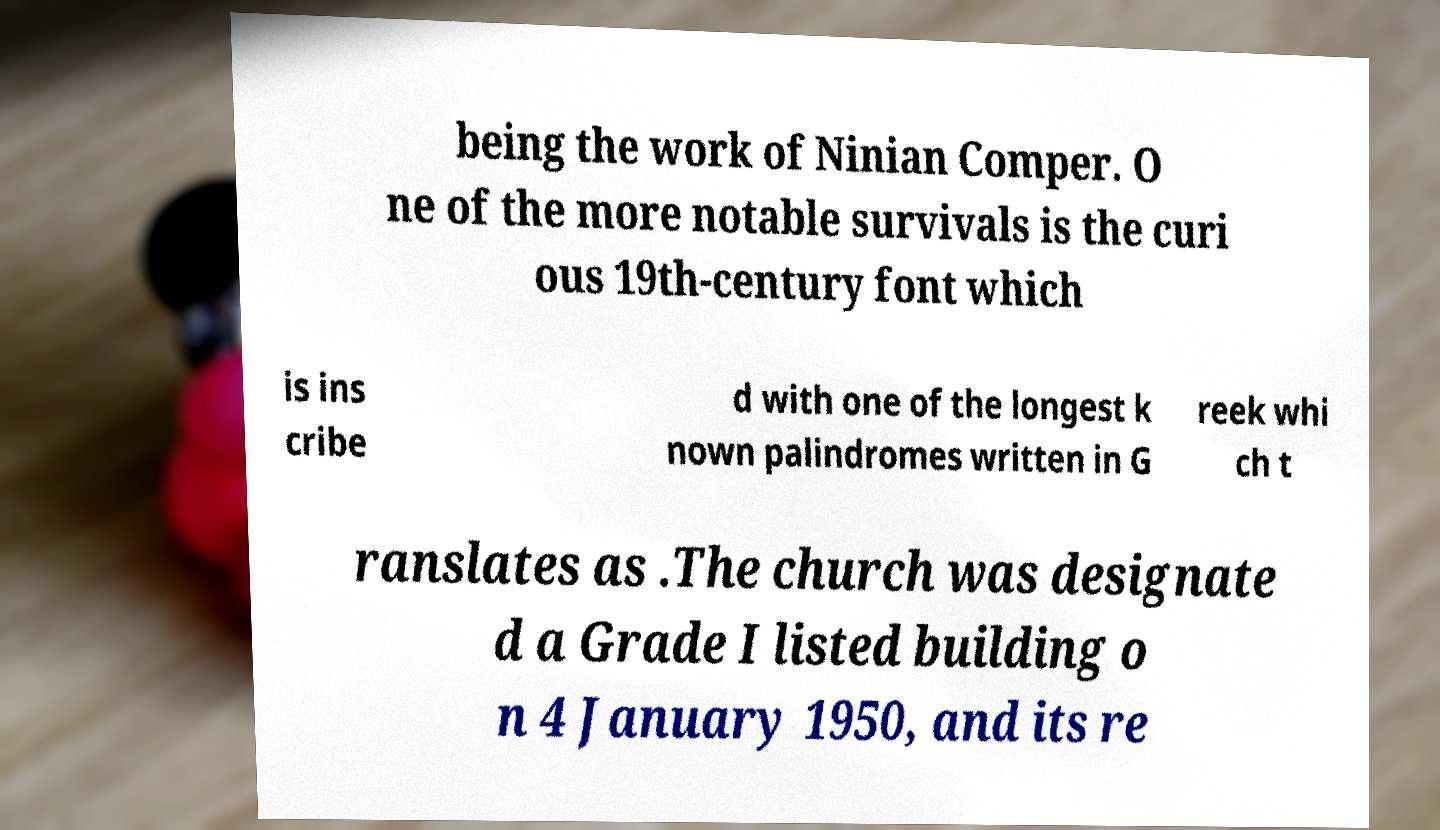Can you accurately transcribe the text from the provided image for me? being the work of Ninian Comper. O ne of the more notable survivals is the curi ous 19th-century font which is ins cribe d with one of the longest k nown palindromes written in G reek whi ch t ranslates as .The church was designate d a Grade I listed building o n 4 January 1950, and its re 